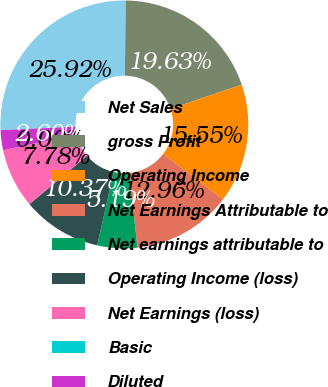Convert chart to OTSL. <chart><loc_0><loc_0><loc_500><loc_500><pie_chart><fcel>Net Sales<fcel>gross Profit<fcel>Operating Income<fcel>Net Earnings Attributable to<fcel>Net earnings attributable to<fcel>Operating Income (loss)<fcel>Net Earnings (loss)<fcel>Basic<fcel>Diluted<nl><fcel>25.92%<fcel>19.63%<fcel>15.55%<fcel>12.96%<fcel>5.19%<fcel>10.37%<fcel>7.78%<fcel>0.0%<fcel>2.6%<nl></chart> 